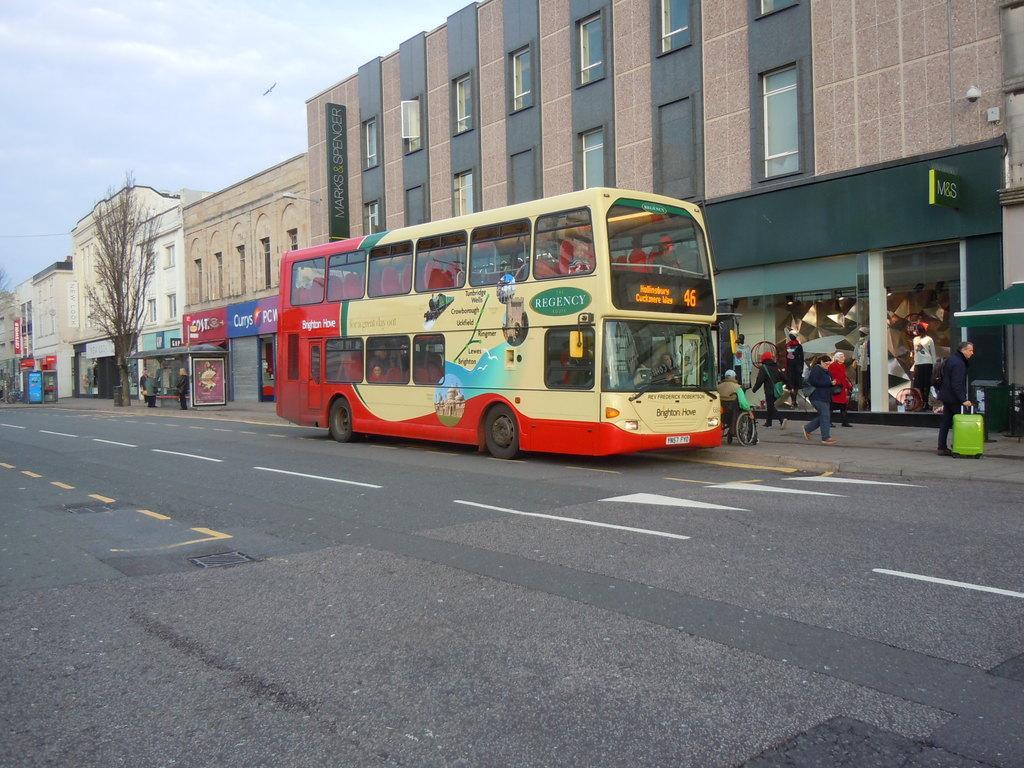In one or two sentences, can you explain what this image depicts? In this image I see the road and I see a bus over here on which there is something written and I see few people. In the background I see the buildings and I see a tree over here and I see the sky and I see few boards on which there is something written too. 